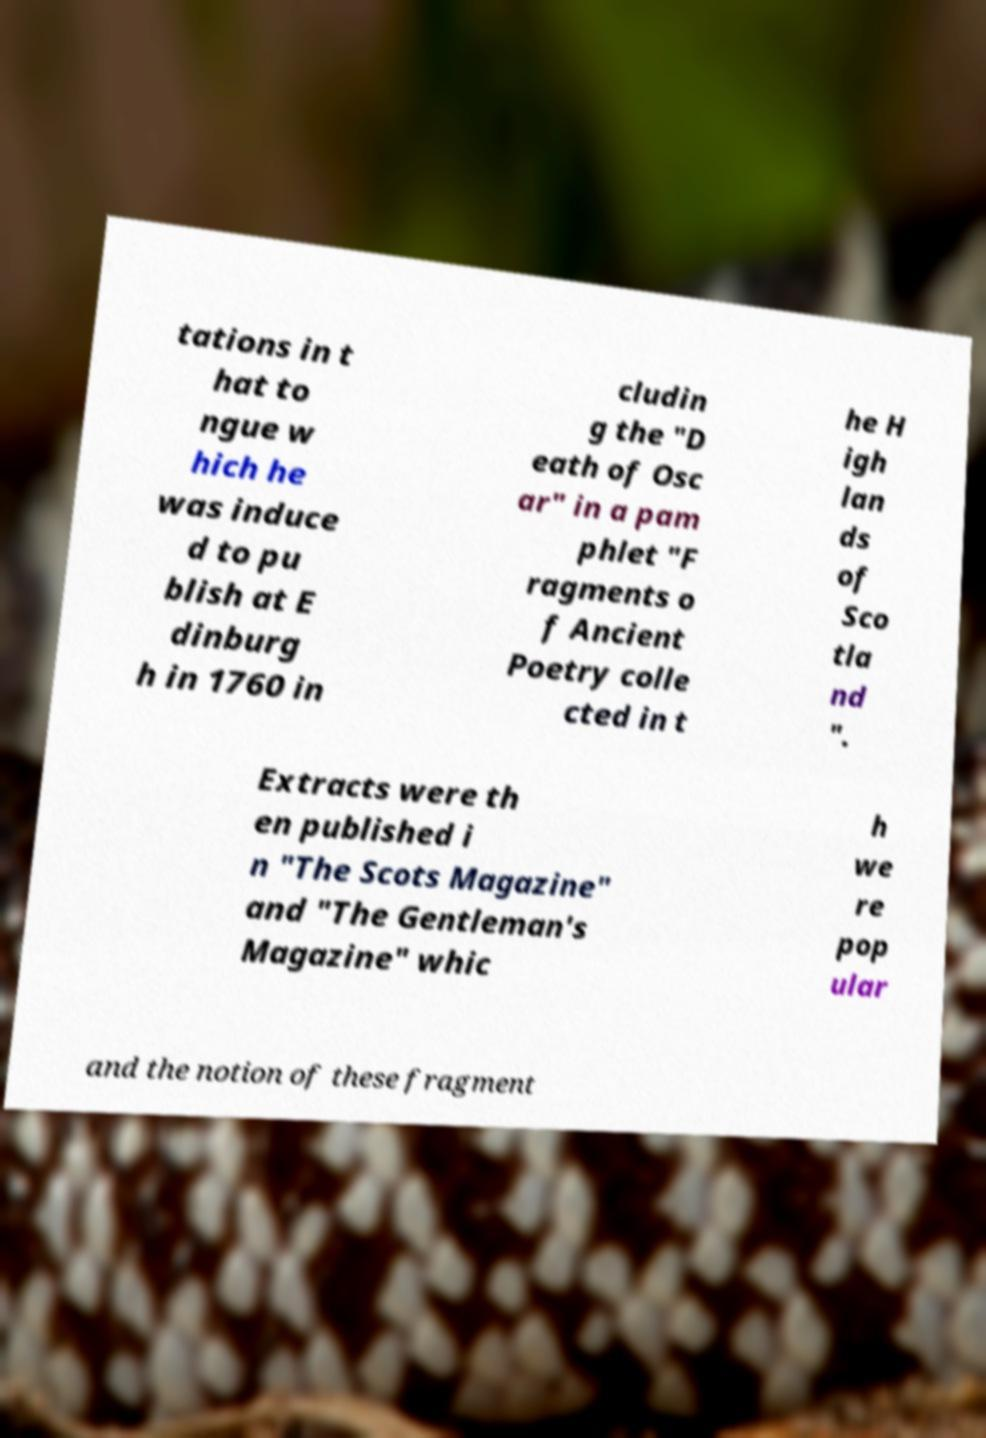Could you assist in decoding the text presented in this image and type it out clearly? tations in t hat to ngue w hich he was induce d to pu blish at E dinburg h in 1760 in cludin g the "D eath of Osc ar" in a pam phlet "F ragments o f Ancient Poetry colle cted in t he H igh lan ds of Sco tla nd ". Extracts were th en published i n "The Scots Magazine" and "The Gentleman's Magazine" whic h we re pop ular and the notion of these fragment 